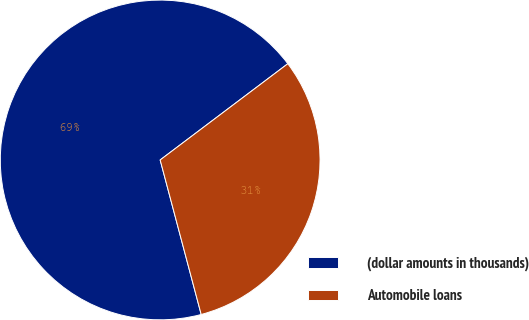Convert chart. <chart><loc_0><loc_0><loc_500><loc_500><pie_chart><fcel>(dollar amounts in thousands)<fcel>Automobile loans<nl><fcel>68.85%<fcel>31.15%<nl></chart> 